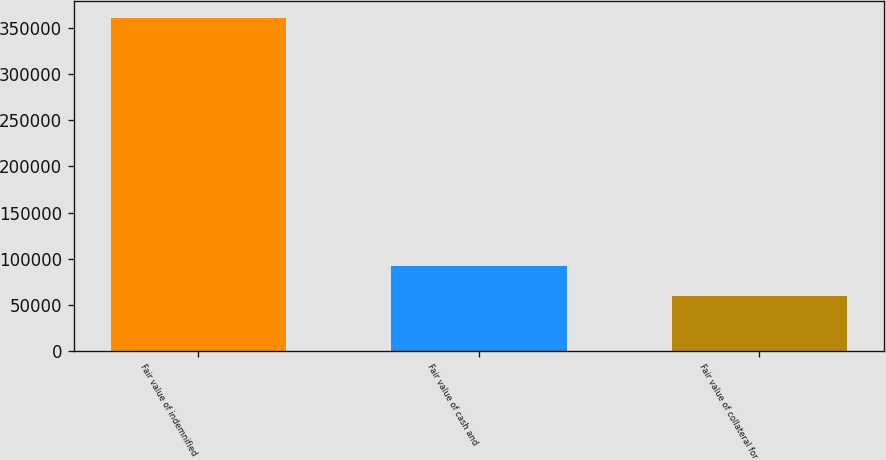<chart> <loc_0><loc_0><loc_500><loc_500><bar_chart><fcel>Fair value of indemnified<fcel>Fair value of cash and<fcel>Fair value of collateral for<nl><fcel>360452<fcel>91794.6<fcel>60003<nl></chart> 